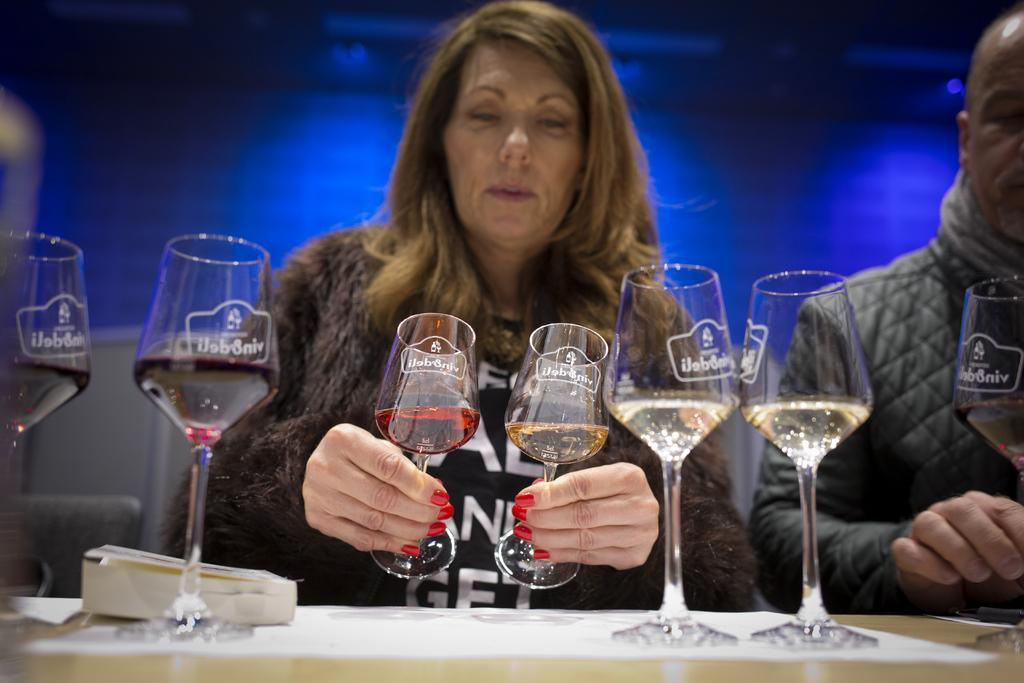Who is the main subject in the image? There is a woman in the center of the image. What is the woman holding in her hands? The woman is holding two glasses in her hands. Can you describe the man in the image? There is a man on the right side of the image. What color is the crayon the woman is using to draw on the baseball in the image? There is no crayon or baseball present in the image. 